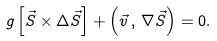Convert formula to latex. <formula><loc_0><loc_0><loc_500><loc_500>g \left [ \vec { S } \times \Delta \vec { S } \right ] + \left ( \vec { v } \, , \, \nabla \vec { S } \right ) = 0 .</formula> 